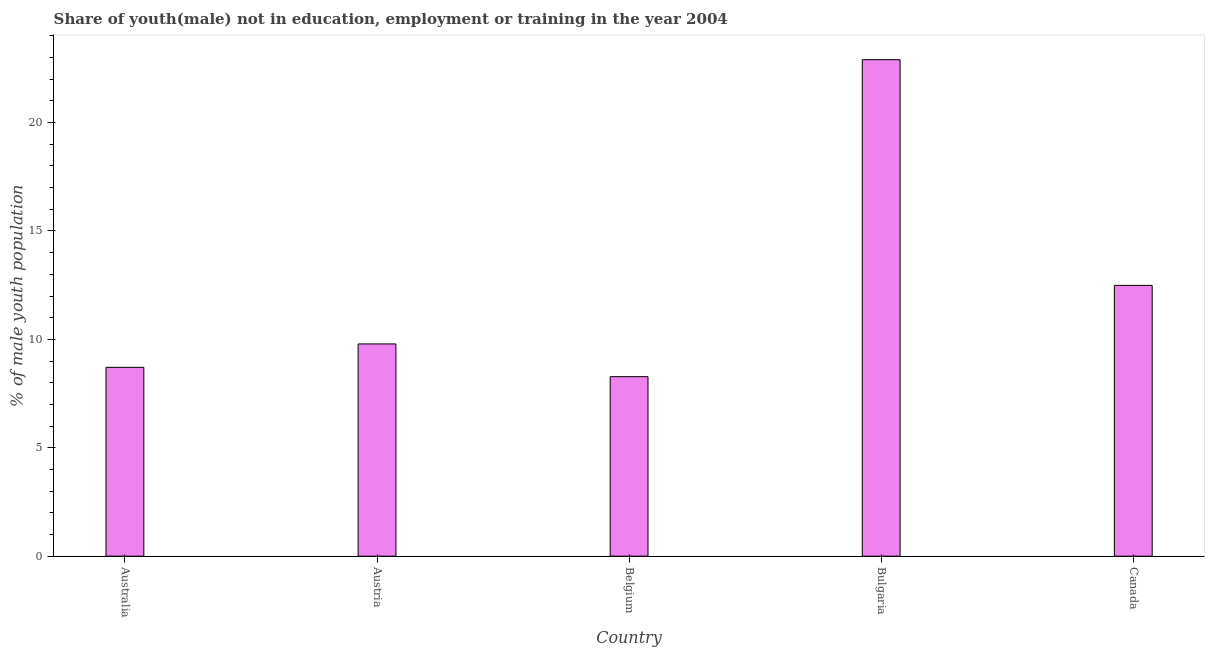What is the title of the graph?
Your response must be concise. Share of youth(male) not in education, employment or training in the year 2004. What is the label or title of the X-axis?
Provide a short and direct response. Country. What is the label or title of the Y-axis?
Offer a terse response. % of male youth population. What is the unemployed male youth population in Australia?
Your answer should be very brief. 8.71. Across all countries, what is the maximum unemployed male youth population?
Ensure brevity in your answer.  22.9. Across all countries, what is the minimum unemployed male youth population?
Your answer should be very brief. 8.28. In which country was the unemployed male youth population minimum?
Make the answer very short. Belgium. What is the sum of the unemployed male youth population?
Ensure brevity in your answer.  62.17. What is the difference between the unemployed male youth population in Australia and Canada?
Provide a short and direct response. -3.78. What is the average unemployed male youth population per country?
Provide a short and direct response. 12.43. What is the median unemployed male youth population?
Ensure brevity in your answer.  9.79. What is the ratio of the unemployed male youth population in Austria to that in Belgium?
Make the answer very short. 1.18. Is the unemployed male youth population in Australia less than that in Belgium?
Provide a short and direct response. No. What is the difference between the highest and the second highest unemployed male youth population?
Offer a terse response. 10.41. Is the sum of the unemployed male youth population in Austria and Bulgaria greater than the maximum unemployed male youth population across all countries?
Make the answer very short. Yes. What is the difference between the highest and the lowest unemployed male youth population?
Make the answer very short. 14.62. How many bars are there?
Give a very brief answer. 5. How many countries are there in the graph?
Ensure brevity in your answer.  5. Are the values on the major ticks of Y-axis written in scientific E-notation?
Give a very brief answer. No. What is the % of male youth population in Australia?
Offer a terse response. 8.71. What is the % of male youth population of Austria?
Your answer should be compact. 9.79. What is the % of male youth population in Belgium?
Offer a terse response. 8.28. What is the % of male youth population in Bulgaria?
Your answer should be compact. 22.9. What is the % of male youth population of Canada?
Provide a succinct answer. 12.49. What is the difference between the % of male youth population in Australia and Austria?
Ensure brevity in your answer.  -1.08. What is the difference between the % of male youth population in Australia and Belgium?
Keep it short and to the point. 0.43. What is the difference between the % of male youth population in Australia and Bulgaria?
Make the answer very short. -14.19. What is the difference between the % of male youth population in Australia and Canada?
Your response must be concise. -3.78. What is the difference between the % of male youth population in Austria and Belgium?
Give a very brief answer. 1.51. What is the difference between the % of male youth population in Austria and Bulgaria?
Keep it short and to the point. -13.11. What is the difference between the % of male youth population in Austria and Canada?
Provide a succinct answer. -2.7. What is the difference between the % of male youth population in Belgium and Bulgaria?
Offer a very short reply. -14.62. What is the difference between the % of male youth population in Belgium and Canada?
Ensure brevity in your answer.  -4.21. What is the difference between the % of male youth population in Bulgaria and Canada?
Ensure brevity in your answer.  10.41. What is the ratio of the % of male youth population in Australia to that in Austria?
Your answer should be very brief. 0.89. What is the ratio of the % of male youth population in Australia to that in Belgium?
Give a very brief answer. 1.05. What is the ratio of the % of male youth population in Australia to that in Bulgaria?
Ensure brevity in your answer.  0.38. What is the ratio of the % of male youth population in Australia to that in Canada?
Make the answer very short. 0.7. What is the ratio of the % of male youth population in Austria to that in Belgium?
Your answer should be compact. 1.18. What is the ratio of the % of male youth population in Austria to that in Bulgaria?
Keep it short and to the point. 0.43. What is the ratio of the % of male youth population in Austria to that in Canada?
Ensure brevity in your answer.  0.78. What is the ratio of the % of male youth population in Belgium to that in Bulgaria?
Make the answer very short. 0.36. What is the ratio of the % of male youth population in Belgium to that in Canada?
Make the answer very short. 0.66. What is the ratio of the % of male youth population in Bulgaria to that in Canada?
Your answer should be compact. 1.83. 